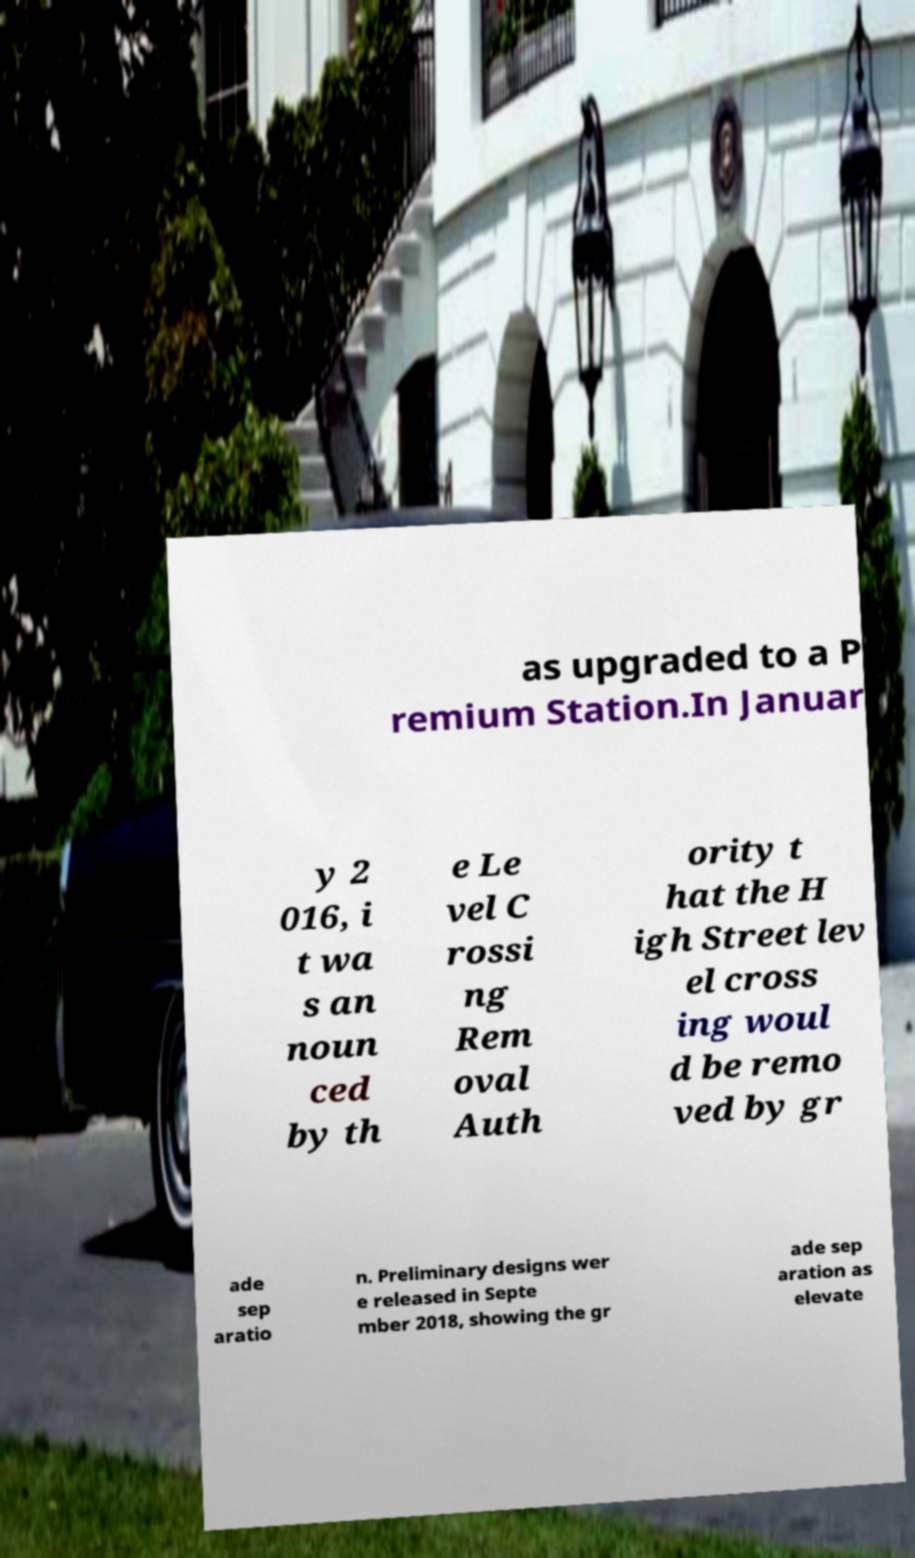Can you read and provide the text displayed in the image?This photo seems to have some interesting text. Can you extract and type it out for me? as upgraded to a P remium Station.In Januar y 2 016, i t wa s an noun ced by th e Le vel C rossi ng Rem oval Auth ority t hat the H igh Street lev el cross ing woul d be remo ved by gr ade sep aratio n. Preliminary designs wer e released in Septe mber 2018, showing the gr ade sep aration as elevate 